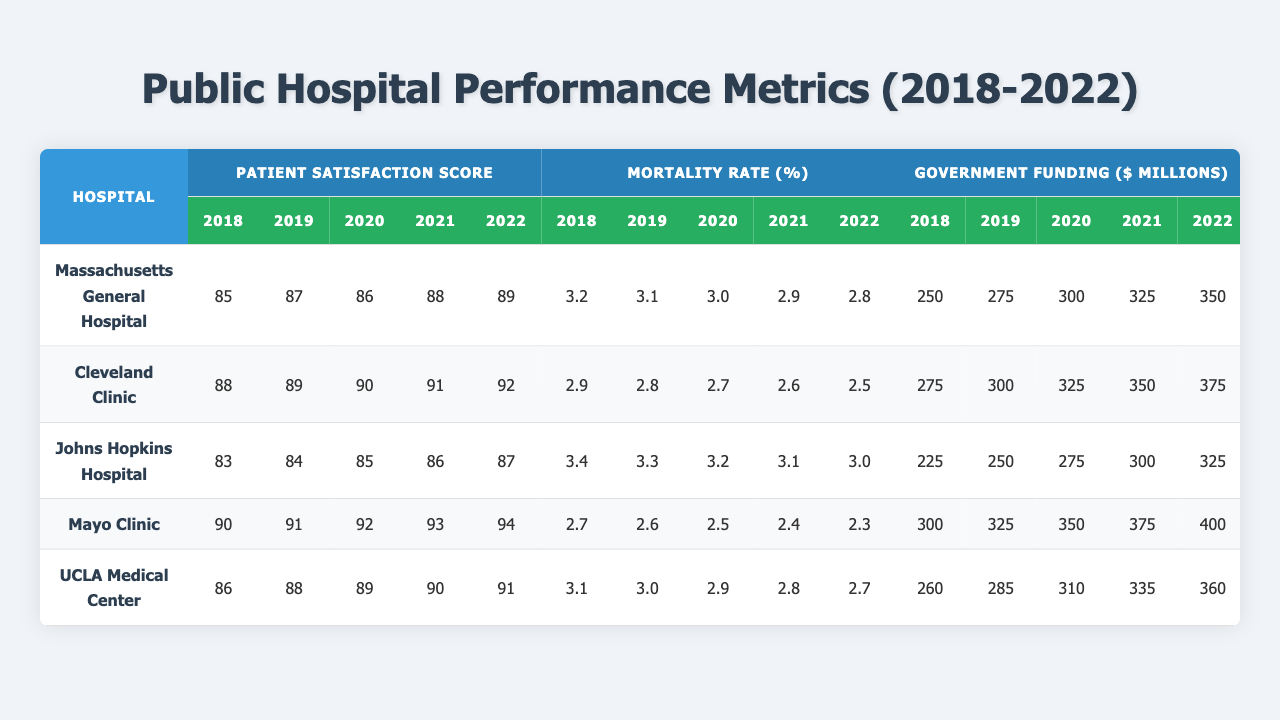What was the patient satisfaction score for Mayo Clinic in 2020? The table shows that the patient satisfaction score for the Mayo Clinic in 2020 is 92.
Answer: 92 What is the mortality rate for Johns Hopkins Hospital in 2022? Referring to the table, the mortality rate for Johns Hopkins Hospital in 2022 is 3.0.
Answer: 3.0 Which hospital had the highest patient satisfaction score in 2022? In the table, for 2022, Mayo Clinic has the highest satisfaction score of 94.
Answer: Mayo Clinic What has been the trend in mortality rates for the Cleveland Clinic from 2018 to 2022? The Cleveland Clinic's mortality rates have decreased from 2.9 in 2018 to 2.5 in 2022, indicating a consistent downward trend.
Answer: Decreasing What is the average patient satisfaction score for Massachusetts General Hospital over the years? Summing the scores: (85 + 87 + 86 + 88 + 89) = 435, divided by 5 gives an average of 87.
Answer: 87 Did UCLA Medical Center receive more government funding in 2021 than in 2019? The table indicates that UCLA Medical Center received $325 million in 2021 and $285 million in 2019, which means it received more in 2021.
Answer: Yes Which hospital had the best staff-to-patient ratio in 2022? Looking at the 2022 data, Mayo Clinic has the highest ratio of 2.2 in 2022.
Answer: Mayo Clinic If we compare the patient satisfaction score for 2018 and 2022 for both Massachusetts General Hospital and John Hopkins Hospital, which hospital showed a greater increase? Massachusetts General Hospital increased from 85 in 2018 to 89 in 2022 (+4 points), while Johns Hopkins Hospital went from 83 in 2018 to 87 in 2022 (+4 points), meaning both showed the same increase in patient satisfaction.
Answer: Equal increase What is the relationship between government funding and mortality rates for the hospitals in 2022? In 2022, hospitals with higher government funding generally have lower mortality rates, as seen with Cleveland Clinic ($375 million, 2.5%) and Mayo Clinic ($400 million, 2.3%).
Answer: Negative correlation What has been the average length of stay for Cleveland Clinic from 2018 to 2022? The calculation for average length of stay is (4.9 + 4.8 + 4.7 + 4.6 + 4.5) = 24.5 days, dividing by 5 gives an average of 4.9 days.
Answer: 4.9 days 